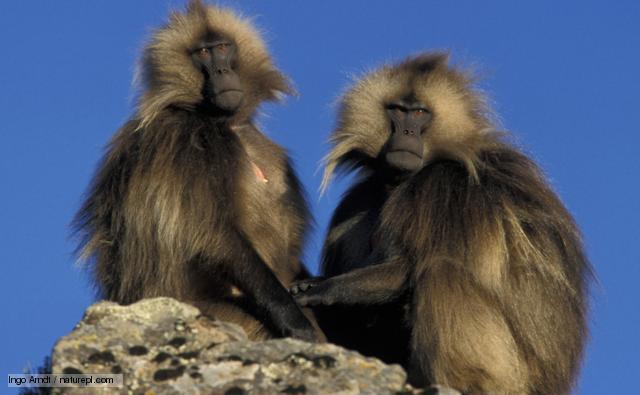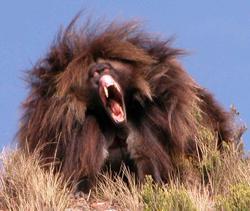The first image is the image on the left, the second image is the image on the right. For the images shown, is this caption "in the right pic the fangs of the monkey is shown" true? Answer yes or no. Yes. The first image is the image on the left, the second image is the image on the right. Given the left and right images, does the statement "There is a total of 1 baboon eating while sitting down." hold true? Answer yes or no. No. 